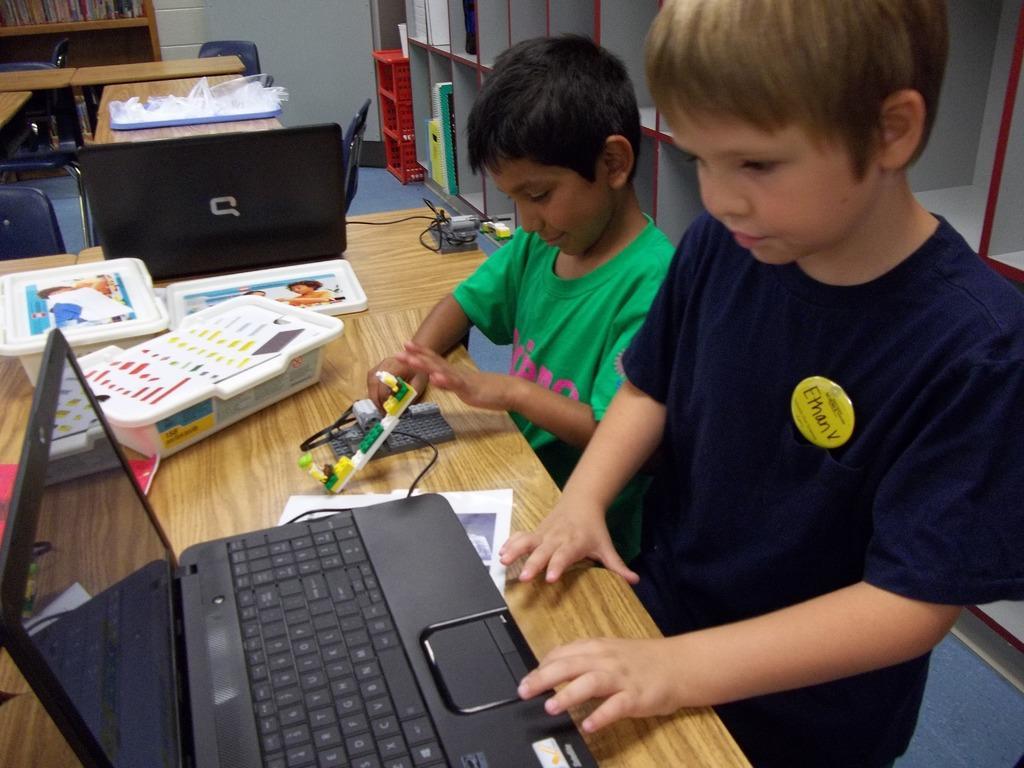Please provide a concise description of this image. There are two children. This is table. On the table there are laptops, boxes, paper, and a toy. This is floor and there is a rack. Here we can see some books and these are the chairs. And there is a tray. 